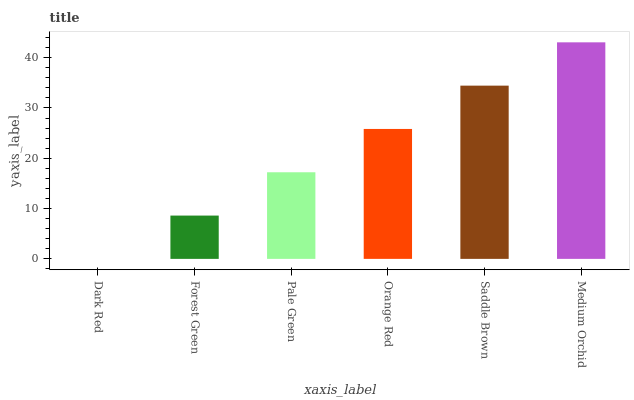Is Dark Red the minimum?
Answer yes or no. Yes. Is Medium Orchid the maximum?
Answer yes or no. Yes. Is Forest Green the minimum?
Answer yes or no. No. Is Forest Green the maximum?
Answer yes or no. No. Is Forest Green greater than Dark Red?
Answer yes or no. Yes. Is Dark Red less than Forest Green?
Answer yes or no. Yes. Is Dark Red greater than Forest Green?
Answer yes or no. No. Is Forest Green less than Dark Red?
Answer yes or no. No. Is Orange Red the high median?
Answer yes or no. Yes. Is Pale Green the low median?
Answer yes or no. Yes. Is Pale Green the high median?
Answer yes or no. No. Is Dark Red the low median?
Answer yes or no. No. 